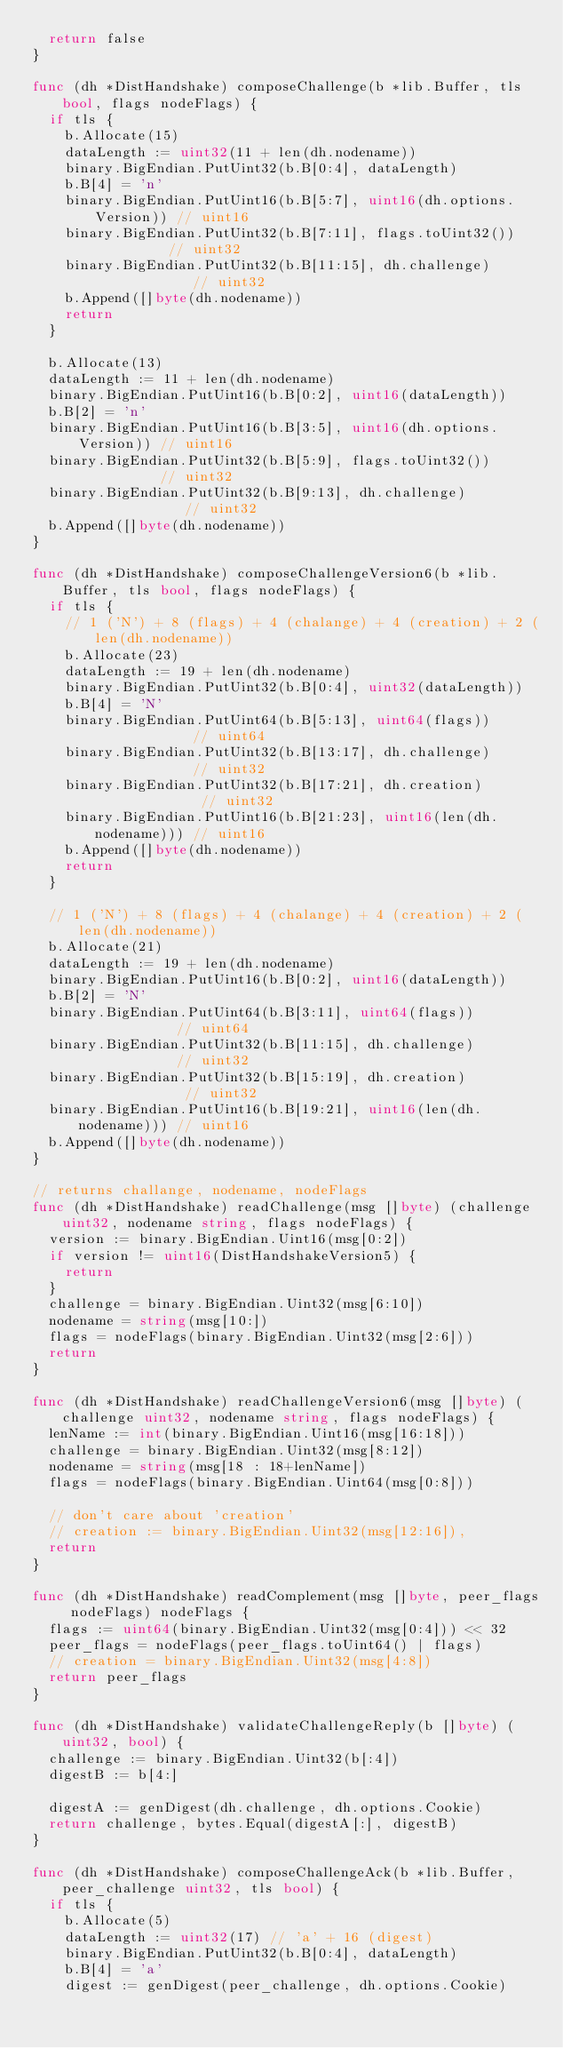Convert code to text. <code><loc_0><loc_0><loc_500><loc_500><_Go_>	return false
}

func (dh *DistHandshake) composeChallenge(b *lib.Buffer, tls bool, flags nodeFlags) {
	if tls {
		b.Allocate(15)
		dataLength := uint32(11 + len(dh.nodename))
		binary.BigEndian.PutUint32(b.B[0:4], dataLength)
		b.B[4] = 'n'
		binary.BigEndian.PutUint16(b.B[5:7], uint16(dh.options.Version)) // uint16
		binary.BigEndian.PutUint32(b.B[7:11], flags.toUint32())          // uint32
		binary.BigEndian.PutUint32(b.B[11:15], dh.challenge)             // uint32
		b.Append([]byte(dh.nodename))
		return
	}

	b.Allocate(13)
	dataLength := 11 + len(dh.nodename)
	binary.BigEndian.PutUint16(b.B[0:2], uint16(dataLength))
	b.B[2] = 'n'
	binary.BigEndian.PutUint16(b.B[3:5], uint16(dh.options.Version)) // uint16
	binary.BigEndian.PutUint32(b.B[5:9], flags.toUint32())           // uint32
	binary.BigEndian.PutUint32(b.B[9:13], dh.challenge)              // uint32
	b.Append([]byte(dh.nodename))
}

func (dh *DistHandshake) composeChallengeVersion6(b *lib.Buffer, tls bool, flags nodeFlags) {
	if tls {
		// 1 ('N') + 8 (flags) + 4 (chalange) + 4 (creation) + 2 (len(dh.nodename))
		b.Allocate(23)
		dataLength := 19 + len(dh.nodename)
		binary.BigEndian.PutUint32(b.B[0:4], uint32(dataLength))
		b.B[4] = 'N'
		binary.BigEndian.PutUint64(b.B[5:13], uint64(flags))             // uint64
		binary.BigEndian.PutUint32(b.B[13:17], dh.challenge)             // uint32
		binary.BigEndian.PutUint32(b.B[17:21], dh.creation)              // uint32
		binary.BigEndian.PutUint16(b.B[21:23], uint16(len(dh.nodename))) // uint16
		b.Append([]byte(dh.nodename))
		return
	}

	// 1 ('N') + 8 (flags) + 4 (chalange) + 4 (creation) + 2 (len(dh.nodename))
	b.Allocate(21)
	dataLength := 19 + len(dh.nodename)
	binary.BigEndian.PutUint16(b.B[0:2], uint16(dataLength))
	b.B[2] = 'N'
	binary.BigEndian.PutUint64(b.B[3:11], uint64(flags))             // uint64
	binary.BigEndian.PutUint32(b.B[11:15], dh.challenge)             // uint32
	binary.BigEndian.PutUint32(b.B[15:19], dh.creation)              // uint32
	binary.BigEndian.PutUint16(b.B[19:21], uint16(len(dh.nodename))) // uint16
	b.Append([]byte(dh.nodename))
}

// returns challange, nodename, nodeFlags
func (dh *DistHandshake) readChallenge(msg []byte) (challenge uint32, nodename string, flags nodeFlags) {
	version := binary.BigEndian.Uint16(msg[0:2])
	if version != uint16(DistHandshakeVersion5) {
		return
	}
	challenge = binary.BigEndian.Uint32(msg[6:10])
	nodename = string(msg[10:])
	flags = nodeFlags(binary.BigEndian.Uint32(msg[2:6]))
	return
}

func (dh *DistHandshake) readChallengeVersion6(msg []byte) (challenge uint32, nodename string, flags nodeFlags) {
	lenName := int(binary.BigEndian.Uint16(msg[16:18]))
	challenge = binary.BigEndian.Uint32(msg[8:12])
	nodename = string(msg[18 : 18+lenName])
	flags = nodeFlags(binary.BigEndian.Uint64(msg[0:8]))

	// don't care about 'creation'
	// creation := binary.BigEndian.Uint32(msg[12:16]),
	return
}

func (dh *DistHandshake) readComplement(msg []byte, peer_flags nodeFlags) nodeFlags {
	flags := uint64(binary.BigEndian.Uint32(msg[0:4])) << 32
	peer_flags = nodeFlags(peer_flags.toUint64() | flags)
	// creation = binary.BigEndian.Uint32(msg[4:8])
	return peer_flags
}

func (dh *DistHandshake) validateChallengeReply(b []byte) (uint32, bool) {
	challenge := binary.BigEndian.Uint32(b[:4])
	digestB := b[4:]

	digestA := genDigest(dh.challenge, dh.options.Cookie)
	return challenge, bytes.Equal(digestA[:], digestB)
}

func (dh *DistHandshake) composeChallengeAck(b *lib.Buffer, peer_challenge uint32, tls bool) {
	if tls {
		b.Allocate(5)
		dataLength := uint32(17) // 'a' + 16 (digest)
		binary.BigEndian.PutUint32(b.B[0:4], dataLength)
		b.B[4] = 'a'
		digest := genDigest(peer_challenge, dh.options.Cookie)</code> 